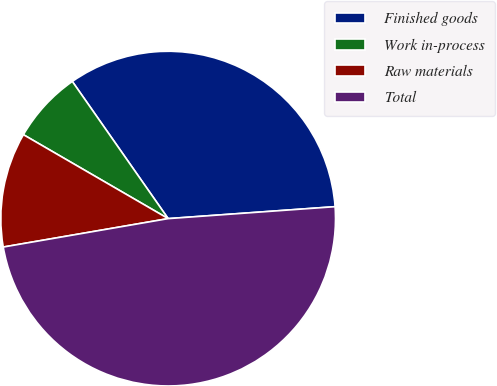Convert chart to OTSL. <chart><loc_0><loc_0><loc_500><loc_500><pie_chart><fcel>Finished goods<fcel>Work in-process<fcel>Raw materials<fcel>Total<nl><fcel>33.57%<fcel>6.93%<fcel>11.08%<fcel>48.42%<nl></chart> 